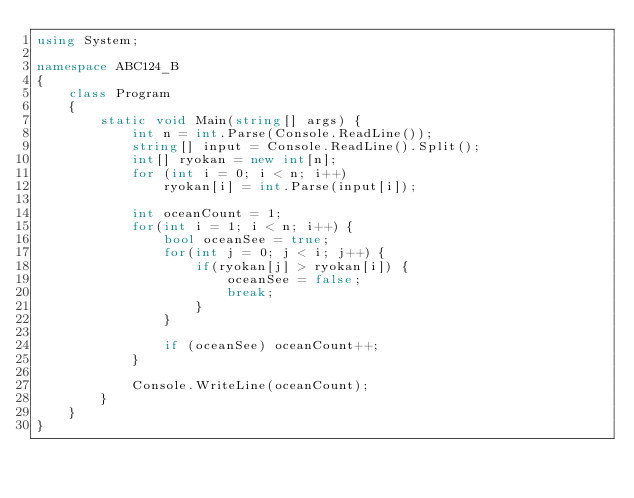<code> <loc_0><loc_0><loc_500><loc_500><_C#_>using System;

namespace ABC124_B
{
    class Program
    {
        static void Main(string[] args) {
            int n = int.Parse(Console.ReadLine());
            string[] input = Console.ReadLine().Split();
            int[] ryokan = new int[n];
            for (int i = 0; i < n; i++)
                ryokan[i] = int.Parse(input[i]);

            int oceanCount = 1;
            for(int i = 1; i < n; i++) {
                bool oceanSee = true;
                for(int j = 0; j < i; j++) {
                    if(ryokan[j] > ryokan[i]) {
                        oceanSee = false;
                        break;
                    }
                }

                if (oceanSee) oceanCount++;
            }

            Console.WriteLine(oceanCount);
        }
    }
}</code> 